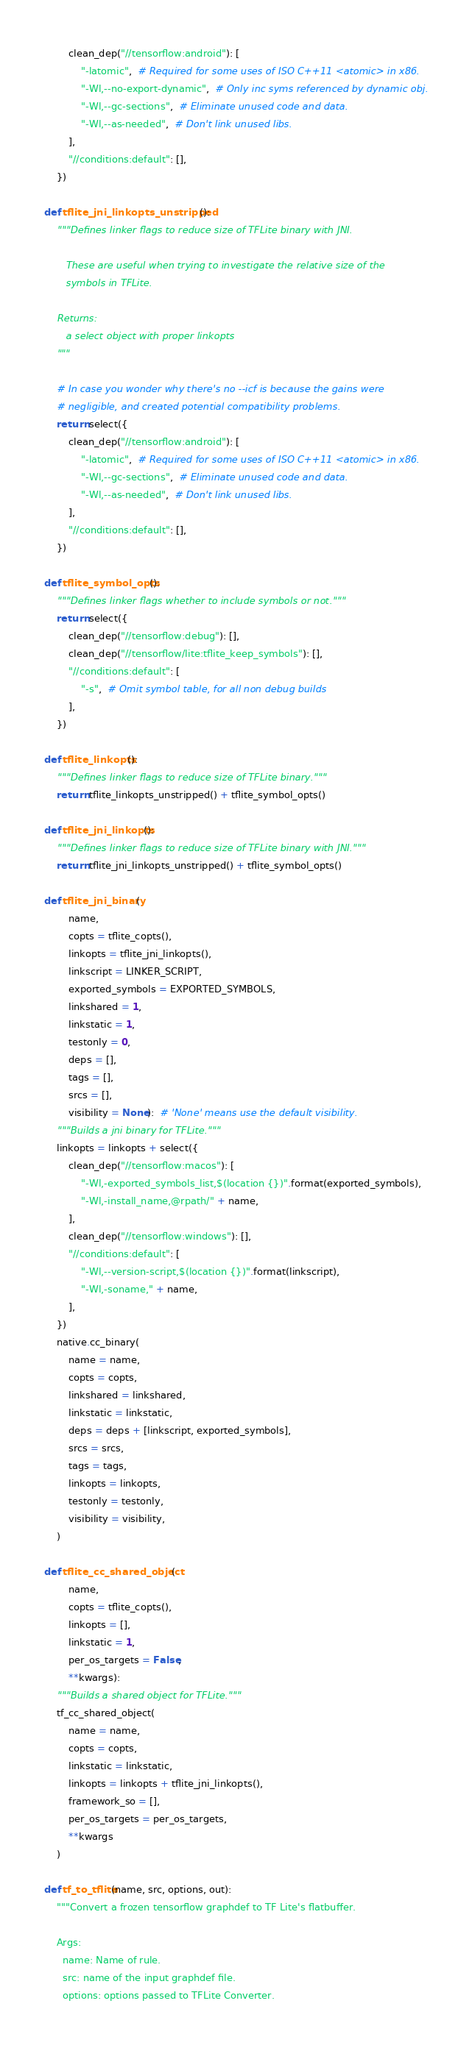Convert code to text. <code><loc_0><loc_0><loc_500><loc_500><_Python_>        clean_dep("//tensorflow:android"): [
            "-latomic",  # Required for some uses of ISO C++11 <atomic> in x86.
            "-Wl,--no-export-dynamic",  # Only inc syms referenced by dynamic obj.
            "-Wl,--gc-sections",  # Eliminate unused code and data.
            "-Wl,--as-needed",  # Don't link unused libs.
        ],
        "//conditions:default": [],
    })

def tflite_jni_linkopts_unstripped():
    """Defines linker flags to reduce size of TFLite binary with JNI.

       These are useful when trying to investigate the relative size of the
       symbols in TFLite.

    Returns:
       a select object with proper linkopts
    """

    # In case you wonder why there's no --icf is because the gains were
    # negligible, and created potential compatibility problems.
    return select({
        clean_dep("//tensorflow:android"): [
            "-latomic",  # Required for some uses of ISO C++11 <atomic> in x86.
            "-Wl,--gc-sections",  # Eliminate unused code and data.
            "-Wl,--as-needed",  # Don't link unused libs.
        ],
        "//conditions:default": [],
    })

def tflite_symbol_opts():
    """Defines linker flags whether to include symbols or not."""
    return select({
        clean_dep("//tensorflow:debug"): [],
        clean_dep("//tensorflow/lite:tflite_keep_symbols"): [],
        "//conditions:default": [
            "-s",  # Omit symbol table, for all non debug builds
        ],
    })

def tflite_linkopts():
    """Defines linker flags to reduce size of TFLite binary."""
    return tflite_linkopts_unstripped() + tflite_symbol_opts()

def tflite_jni_linkopts():
    """Defines linker flags to reduce size of TFLite binary with JNI."""
    return tflite_jni_linkopts_unstripped() + tflite_symbol_opts()

def tflite_jni_binary(
        name,
        copts = tflite_copts(),
        linkopts = tflite_jni_linkopts(),
        linkscript = LINKER_SCRIPT,
        exported_symbols = EXPORTED_SYMBOLS,
        linkshared = 1,
        linkstatic = 1,
        testonly = 0,
        deps = [],
        tags = [],
        srcs = [],
        visibility = None):  # 'None' means use the default visibility.
    """Builds a jni binary for TFLite."""
    linkopts = linkopts + select({
        clean_dep("//tensorflow:macos"): [
            "-Wl,-exported_symbols_list,$(location {})".format(exported_symbols),
            "-Wl,-install_name,@rpath/" + name,
        ],
        clean_dep("//tensorflow:windows"): [],
        "//conditions:default": [
            "-Wl,--version-script,$(location {})".format(linkscript),
            "-Wl,-soname," + name,
        ],
    })
    native.cc_binary(
        name = name,
        copts = copts,
        linkshared = linkshared,
        linkstatic = linkstatic,
        deps = deps + [linkscript, exported_symbols],
        srcs = srcs,
        tags = tags,
        linkopts = linkopts,
        testonly = testonly,
        visibility = visibility,
    )

def tflite_cc_shared_object(
        name,
        copts = tflite_copts(),
        linkopts = [],
        linkstatic = 1,
        per_os_targets = False,
        **kwargs):
    """Builds a shared object for TFLite."""
    tf_cc_shared_object(
        name = name,
        copts = copts,
        linkstatic = linkstatic,
        linkopts = linkopts + tflite_jni_linkopts(),
        framework_so = [],
        per_os_targets = per_os_targets,
        **kwargs
    )

def tf_to_tflite(name, src, options, out):
    """Convert a frozen tensorflow graphdef to TF Lite's flatbuffer.

    Args:
      name: Name of rule.
      src: name of the input graphdef file.
      options: options passed to TFLite Converter.</code> 